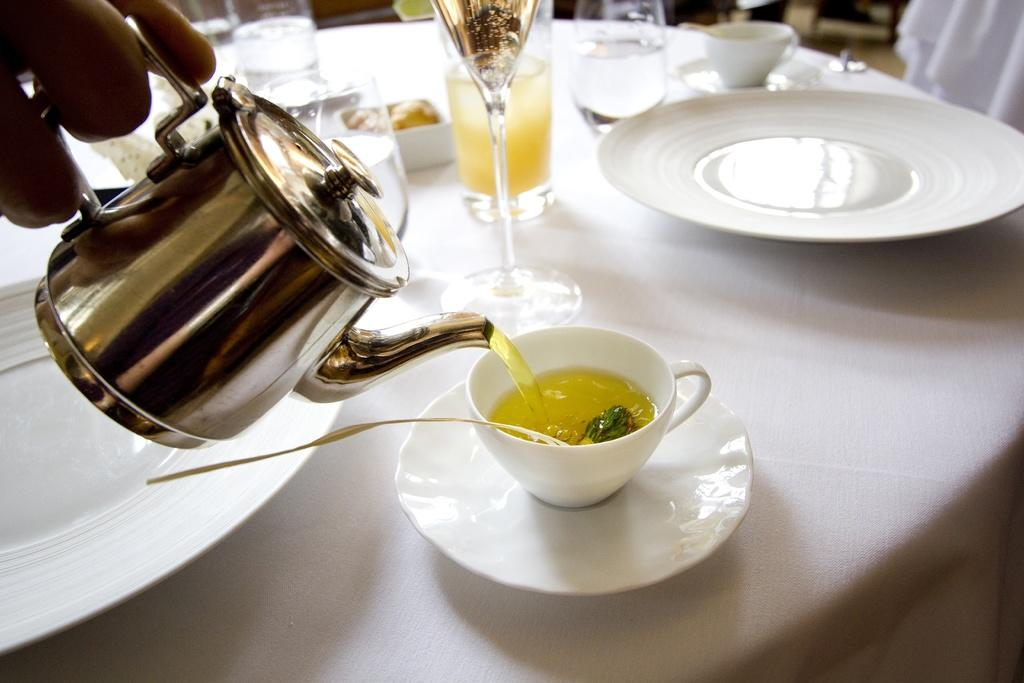What is the person in the image holding near the river? The person is holding a fishing rod. What might the person be doing near the river? The person might be fishing. Can you describe the surroundings of the person in the image? The person is standing near a river. How much money did the giants bring on their holiday in the image? There are no giants or mention of a holiday in the image; it features a person standing near a river holding a fishing rod. 